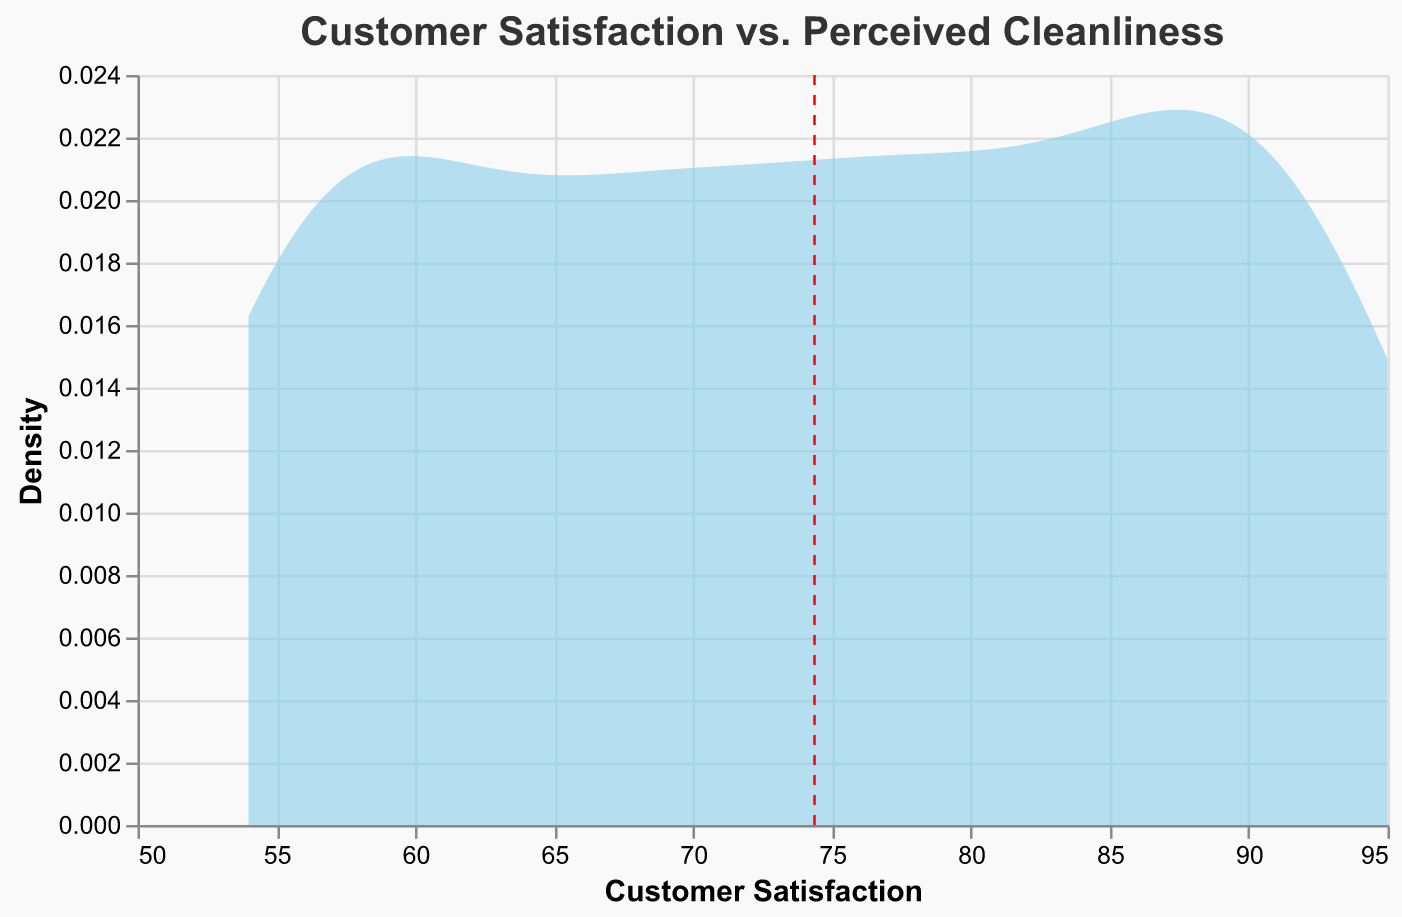What is the title of the plot? The title is clearly written at the top of the plot in a font size and color that makes it easily visible.
Answer: Customer Satisfaction vs. Perceived Cleanliness What do the x and y axes represent? The x-axis represents "Customer Satisfaction" and the y-axis represents "Density," as labeled on each respective axis.
Answer: Customer Satisfaction, Density What color is used to represent the density area in the plot? The density area is shaded with a color that is visually distinct to represent the data clearly.
Answer: Skyblue What does the red dashed vertical line represent in the plot? The red dashed vertical line marks the mean of Customer Satisfaction. The color and pattern are used to differentiate it from other plot elements.
Answer: Mean Customer Satisfaction What is the approximate mean value of Customer Satisfaction as indicated by the vertical line? You need to look at where the red dashed line intersects the x-axis to find the mean Customer Satisfaction value.
Answer: Around 74 How many significant peaks can be identified in the density plot? By observing the density plot, the number of prominent peaks can be counted.
Answer: Two Compare the peak customer satisfaction levels. Which peak has a higher density? First, identify the peaks in the density plot. Then, compare the heights of these peaks to determine which one is higher.
Answer: The first peak What is the range of Customer Satisfaction scores in the data? The range is found by identifying the minimum and maximum values along the x-axis, where the density area extends.
Answer: 54 to 95 Is there a dense cluster of data points at specific Customer Satisfaction scores? Visual inspection of the density plot shows where the density areas are most concentrated.
Answer: Yes Does the plot suggest any correlation between the perceived cleanliness of the neighborhood and customer satisfaction? Although it's not directly plotted, the density and the mean might reflect a correlation if combined with perceived cleanliness scores in analysis.
Answer: Yes 